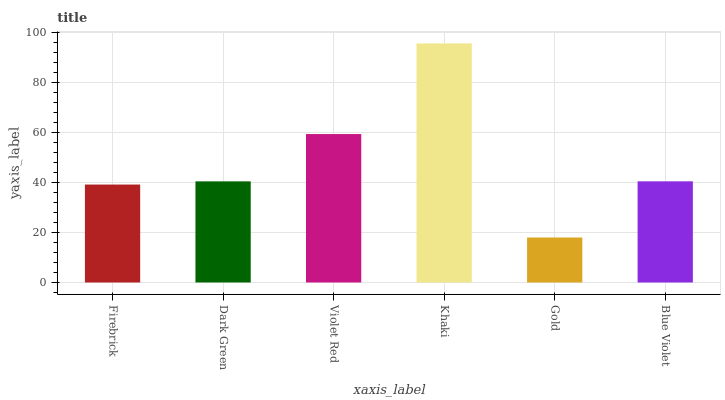Is Gold the minimum?
Answer yes or no. Yes. Is Khaki the maximum?
Answer yes or no. Yes. Is Dark Green the minimum?
Answer yes or no. No. Is Dark Green the maximum?
Answer yes or no. No. Is Dark Green greater than Firebrick?
Answer yes or no. Yes. Is Firebrick less than Dark Green?
Answer yes or no. Yes. Is Firebrick greater than Dark Green?
Answer yes or no. No. Is Dark Green less than Firebrick?
Answer yes or no. No. Is Blue Violet the high median?
Answer yes or no. Yes. Is Dark Green the low median?
Answer yes or no. Yes. Is Violet Red the high median?
Answer yes or no. No. Is Violet Red the low median?
Answer yes or no. No. 